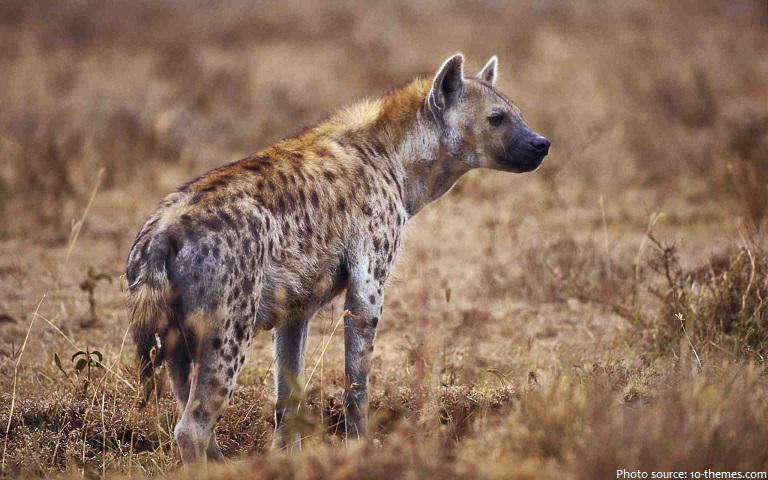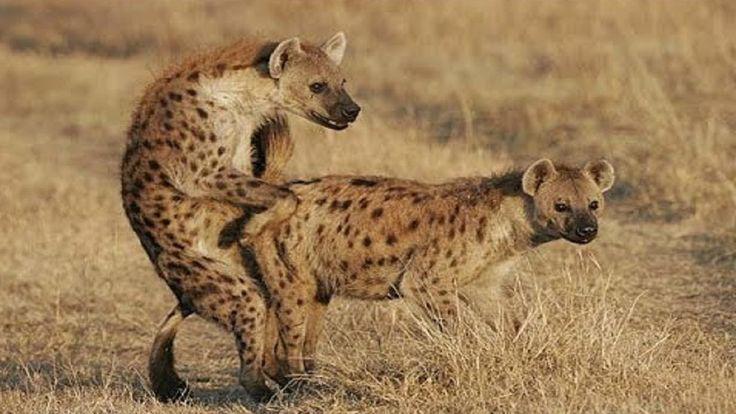The first image is the image on the left, the second image is the image on the right. For the images shown, is this caption "There are two hyenas." true? Answer yes or no. No. 